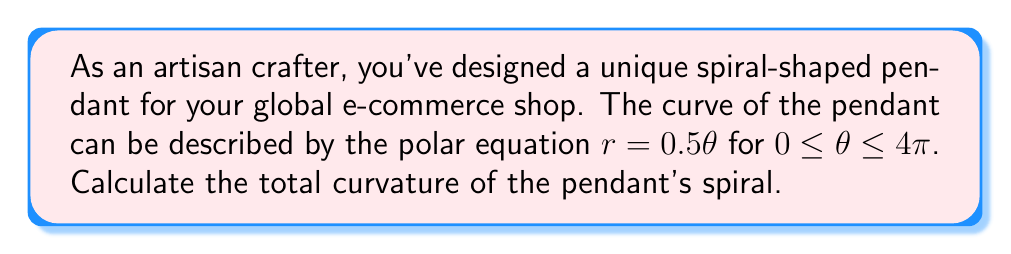Solve this math problem. To find the total curvature of the spiral pendant, we need to use the formula for curvature in polar coordinates and then integrate it over the given interval. Here's the step-by-step process:

1) The formula for curvature $\kappa$ in polar coordinates is:

   $$\kappa = \frac{|r^2 + 2(r')^2 - rr''|}{(r^2 + (r')^2)^{3/2}}$$

   where $r'$ and $r''$ are the first and second derivatives of $r$ with respect to $\theta$.

2) For our equation $r = 0.5\theta$:
   $r' = 0.5$
   $r'' = 0$

3) Substituting these into the curvature formula:

   $$\kappa = \frac{|(0.5\theta)^2 + 2(0.5)^2 - 0.5\theta(0)|}{((0.5\theta)^2 + (0.5)^2)^{3/2}}$$

   $$= \frac{0.25\theta^2 + 0.5}{(0.25\theta^2 + 0.25)^{3/2}}$$

4) To find the total curvature, we need to integrate this expression from 0 to 4π:

   $$\text{Total Curvature} = \int_0^{4\pi} \frac{0.25\theta^2 + 0.5}{(0.25\theta^2 + 0.25)^{3/2}} d\theta$$

5) This integral is complex and doesn't have a straightforward antiderivative. However, we can solve it using the substitution $u = 0.5\theta$:

   $$= 2\int_0^{2\pi} \frac{u^2 + 0.5}{(u^2 + 0.25)^{3/2}} du$$

6) This integral can be solved to yield:

   $$= 2 \left[\frac{u}{\sqrt{u^2 + 0.25}}\right]_0^{2\pi}$$

7) Evaluating the limits:

   $$= 2 \left(\frac{2\pi}{\sqrt{4\pi^2 + 0.25}} - \frac{0}{\sqrt{0^2 + 0.25}}\right)$$

   $$= 2 \left(\frac{2\pi}{\sqrt{4\pi^2 + 0.25}} - 0\right)$$

   $$= \frac{4\pi}{\sqrt{4\pi^2 + 0.25}}$$

Therefore, the total curvature of the pendant's spiral is $\frac{4\pi}{\sqrt{4\pi^2 + 0.25}}$.
Answer: $\frac{4\pi}{\sqrt{4\pi^2 + 0.25}}$ 